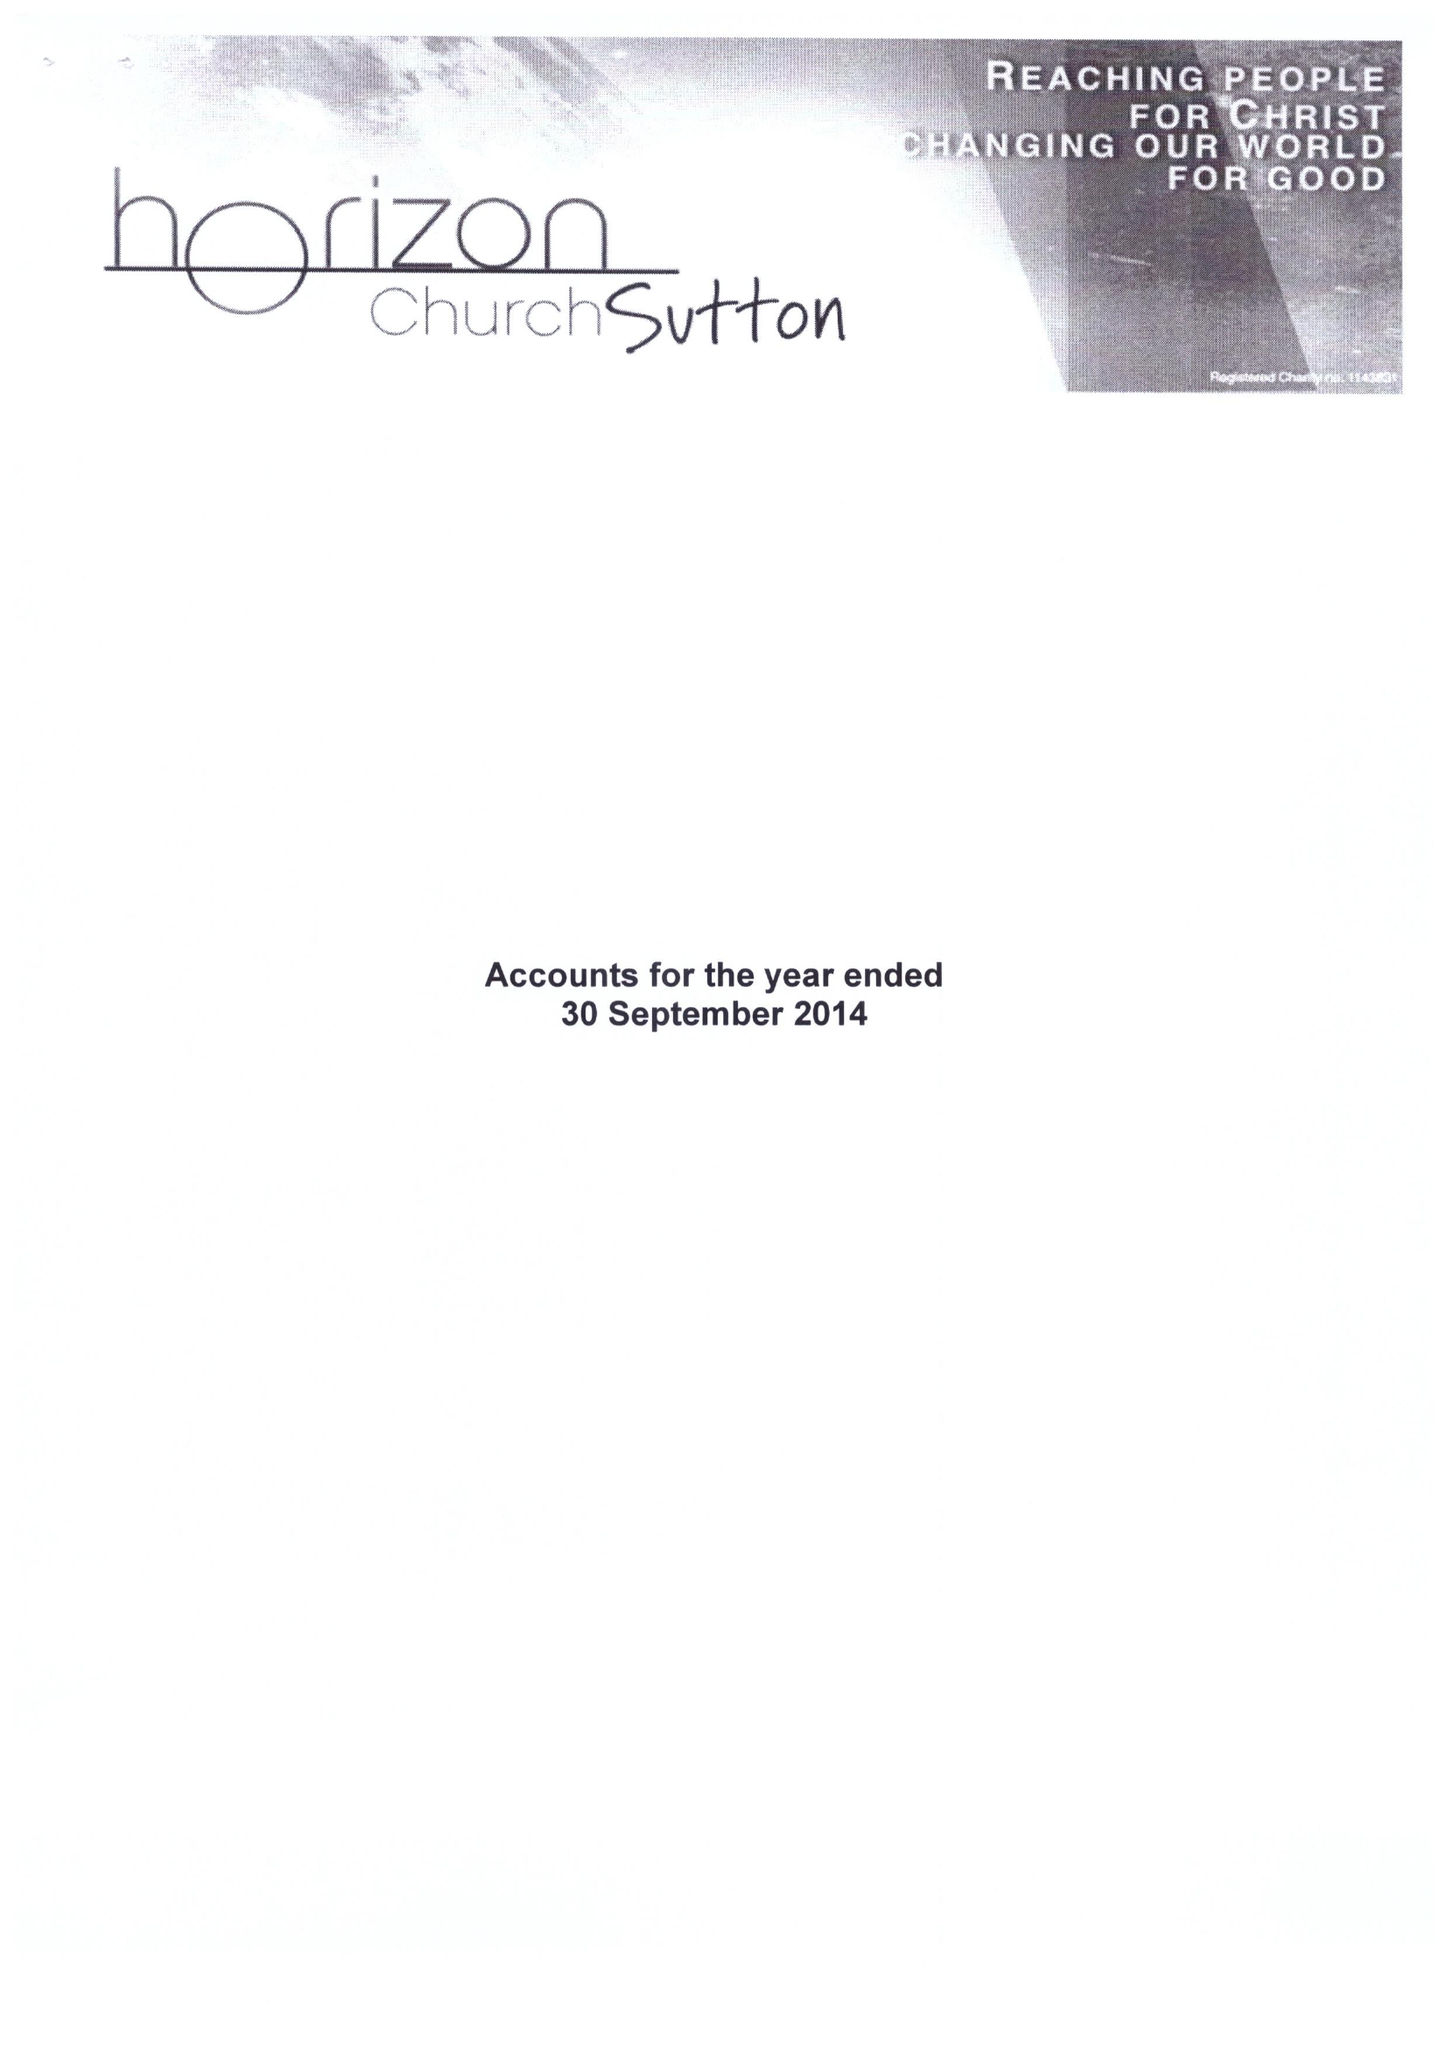What is the value for the report_date?
Answer the question using a single word or phrase. 2014-09-30 